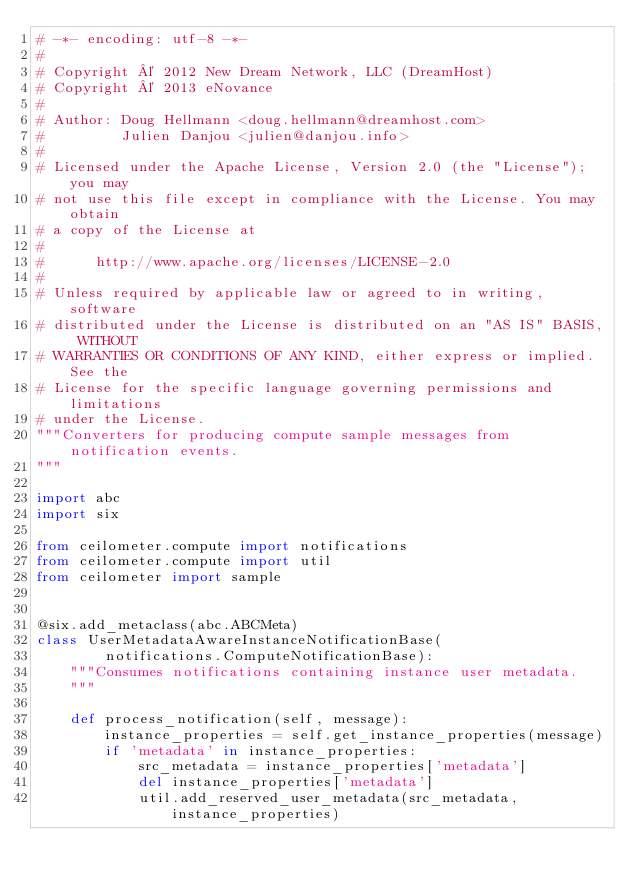Convert code to text. <code><loc_0><loc_0><loc_500><loc_500><_Python_># -*- encoding: utf-8 -*-
#
# Copyright © 2012 New Dream Network, LLC (DreamHost)
# Copyright © 2013 eNovance
#
# Author: Doug Hellmann <doug.hellmann@dreamhost.com>
#         Julien Danjou <julien@danjou.info>
#
# Licensed under the Apache License, Version 2.0 (the "License"); you may
# not use this file except in compliance with the License. You may obtain
# a copy of the License at
#
#      http://www.apache.org/licenses/LICENSE-2.0
#
# Unless required by applicable law or agreed to in writing, software
# distributed under the License is distributed on an "AS IS" BASIS, WITHOUT
# WARRANTIES OR CONDITIONS OF ANY KIND, either express or implied. See the
# License for the specific language governing permissions and limitations
# under the License.
"""Converters for producing compute sample messages from notification events.
"""

import abc
import six

from ceilometer.compute import notifications
from ceilometer.compute import util
from ceilometer import sample


@six.add_metaclass(abc.ABCMeta)
class UserMetadataAwareInstanceNotificationBase(
        notifications.ComputeNotificationBase):
    """Consumes notifications containing instance user metadata.
    """

    def process_notification(self, message):
        instance_properties = self.get_instance_properties(message)
        if 'metadata' in instance_properties:
            src_metadata = instance_properties['metadata']
            del instance_properties['metadata']
            util.add_reserved_user_metadata(src_metadata, instance_properties)</code> 